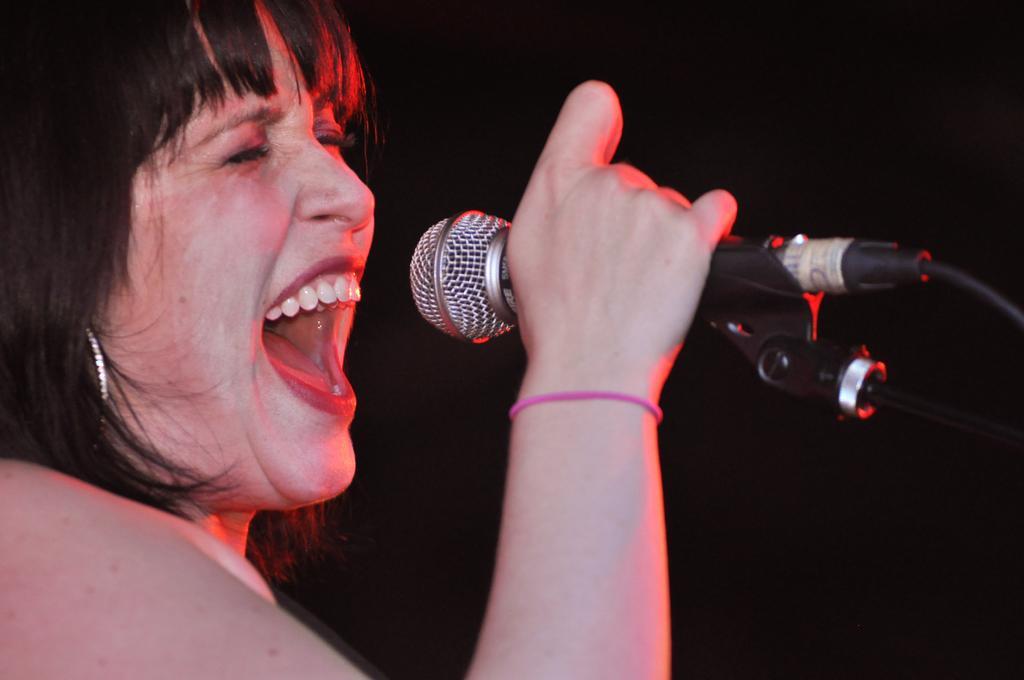Please provide a concise description of this image. In this image there is a woman singing by holding a mic in her hand. 